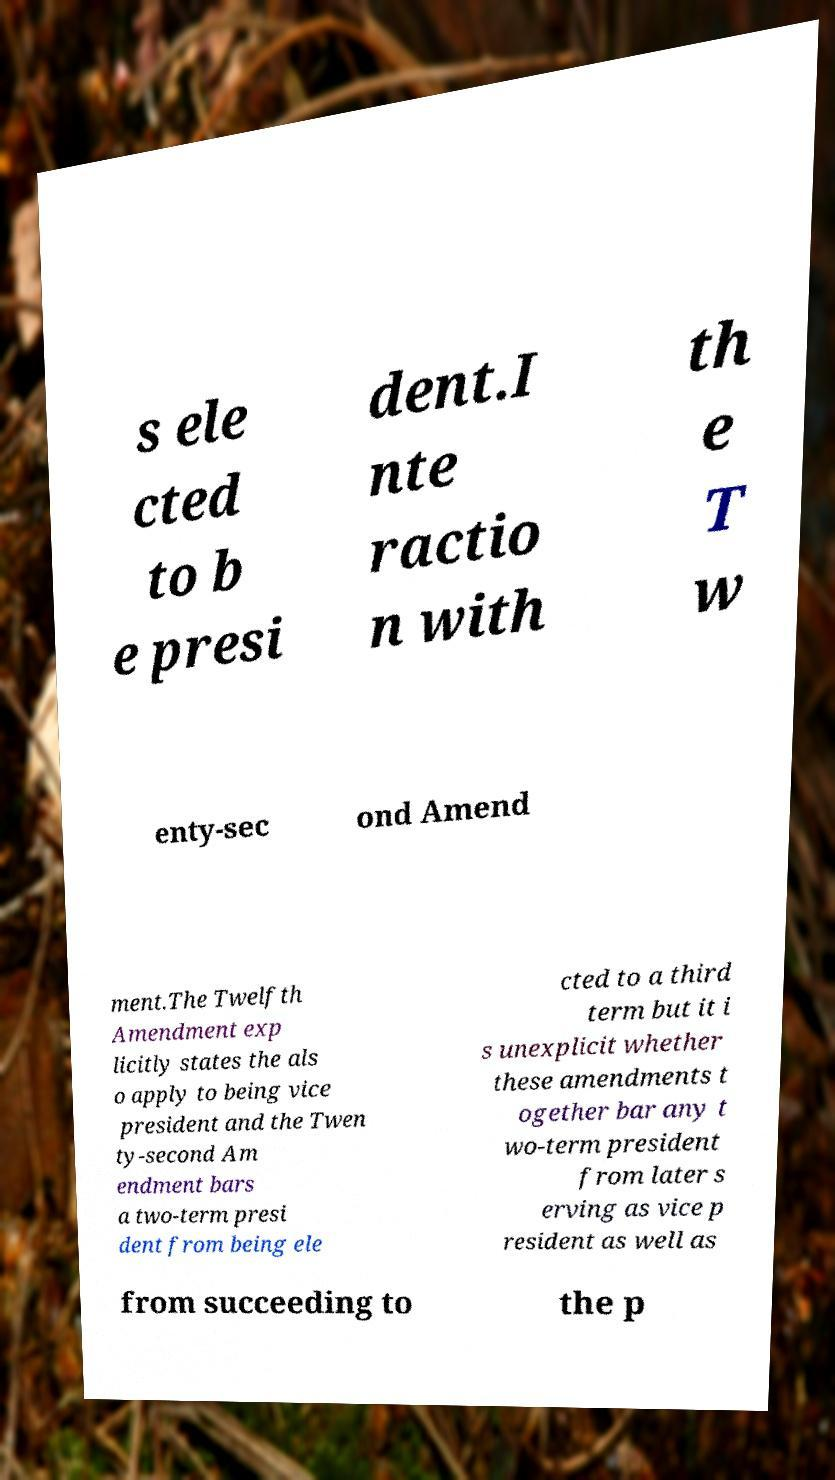Could you assist in decoding the text presented in this image and type it out clearly? s ele cted to b e presi dent.I nte ractio n with th e T w enty-sec ond Amend ment.The Twelfth Amendment exp licitly states the als o apply to being vice president and the Twen ty-second Am endment bars a two-term presi dent from being ele cted to a third term but it i s unexplicit whether these amendments t ogether bar any t wo-term president from later s erving as vice p resident as well as from succeeding to the p 